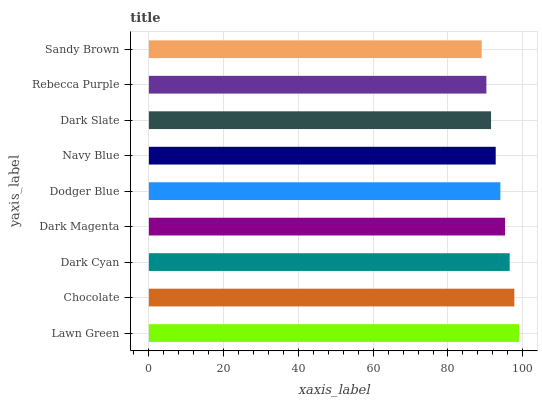Is Sandy Brown the minimum?
Answer yes or no. Yes. Is Lawn Green the maximum?
Answer yes or no. Yes. Is Chocolate the minimum?
Answer yes or no. No. Is Chocolate the maximum?
Answer yes or no. No. Is Lawn Green greater than Chocolate?
Answer yes or no. Yes. Is Chocolate less than Lawn Green?
Answer yes or no. Yes. Is Chocolate greater than Lawn Green?
Answer yes or no. No. Is Lawn Green less than Chocolate?
Answer yes or no. No. Is Dodger Blue the high median?
Answer yes or no. Yes. Is Dodger Blue the low median?
Answer yes or no. Yes. Is Navy Blue the high median?
Answer yes or no. No. Is Chocolate the low median?
Answer yes or no. No. 